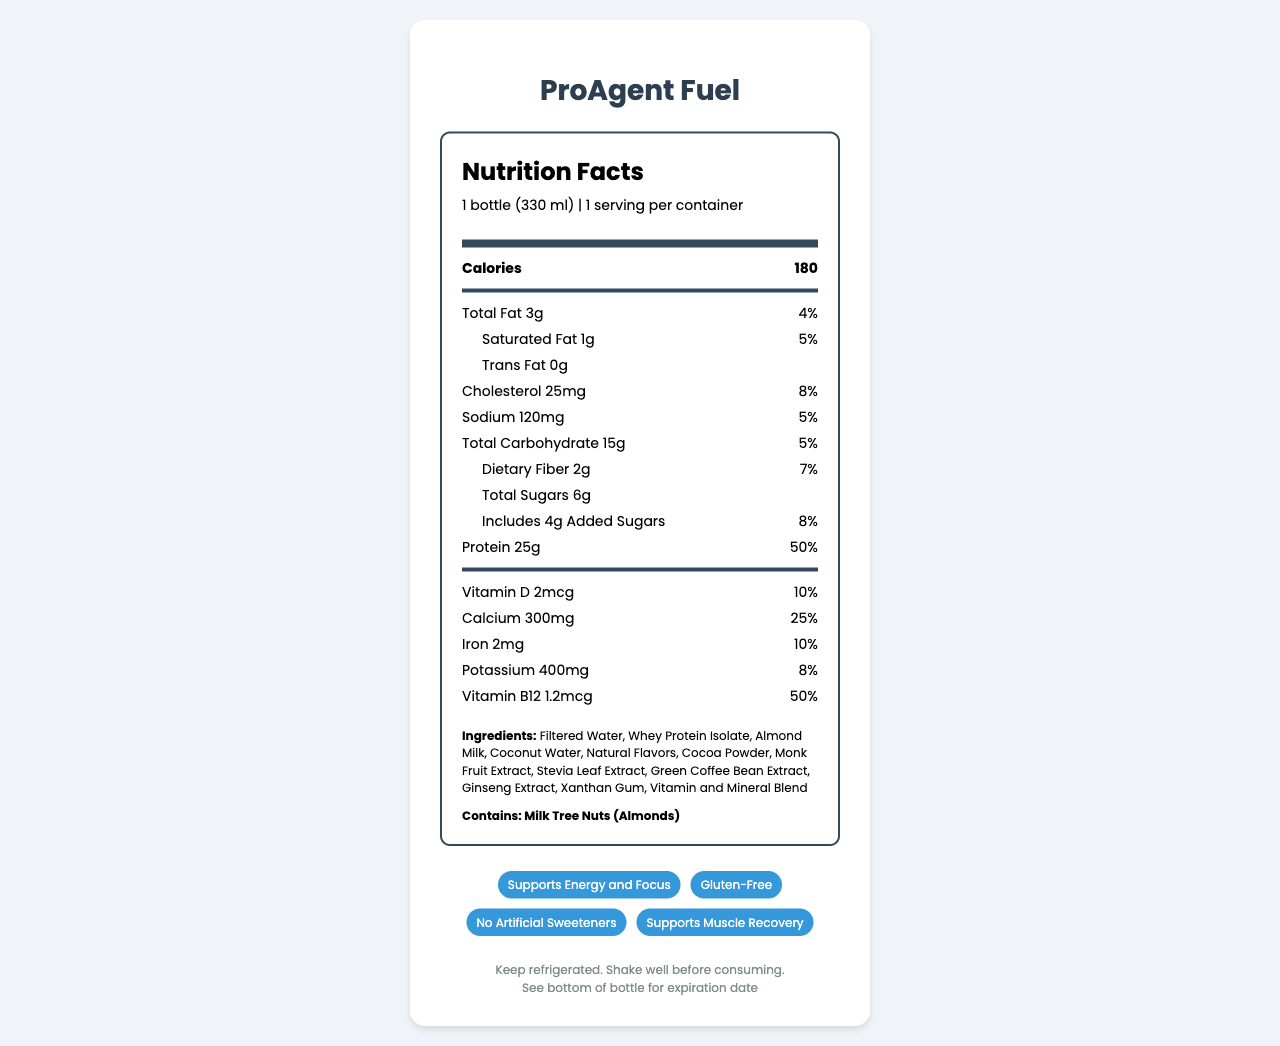what is the serving size of ProAgent Fuel? The serving size is indicated in the serving info section at the top of the nutrition label.
Answer: 1 bottle (330 ml) how many calories are in one serving of ProAgent Fuel? The calorie count is highlighted in a bolder font just below the serving size information.
Answer: 180 how many grams of protein does ProAgent Fuel provide per serving? The amount of protein per serving is listed in the nutrition facts, where it says "Protein 25g".
Answer: 25g what is the daily value percentage for calcium in a serving of ProAgent Fuel? The daily value percentage for calcium is listed next to the amount of calcium in the nutrition facts.
Answer: 25% what are the main ingredients of ProAgent Fuel? The ingredients are listed near the bottom under the "Ingredients" section.
Answer: Filtered Water, Whey Protein Isolate, Almond Milk, Coconut Water, Natural Flavors, Cocoa Powder, Monk Fruit Extract, Stevia Leaf Extract, Green Coffee Bean Extract, Ginseng Extract, Xanthan Gum, Vitamin and Mineral Blend which of the following claims is NOT made about ProAgent Fuel? A. Low Sugar B. Supports Energy and Focus C. Gluten-Free D. Supports Muscle Recovery The document includes claims about supporting energy and focus, being gluten-free, and supporting muscle recovery, but not about being low in sugar.
Answer: A what is the daily value percentage of iron provided in ProAgent Fuel? A. 5% B. 10% C. 20% D. 25% The daily value percentage of iron is indicated as 10% in the nutrition facts.
Answer: B does ProAgent Fuel contain any artificial sweeteners? The document specifically claims "No Artificial Sweeteners".
Answer: No does ProAgent Fuel require refrigeration? The storage information indicates "Keep refrigerated."
Answer: Yes summarize the main features of ProAgent Fuel. The document provides a detailed overview of the nutritional content, ingredients, and health claims of the ProAgent Fuel protein shake, along with storage instructions.
Answer: ProAgent Fuel is a protein shake designed for real estate agents on-the-go. It offers 180 calories per bottle with significant protein content (25g) and various vitamins and minerals. The product contains no artificial sweeteners, is gluten-free, and supports energy, focus, and muscle recovery. It is made with ingredients like whey protein isolate, almond milk, and coconut water. It must be kept refrigerated. what is the flavor of ProAgent Fuel? The document does not specify the flavor, it only mentions natural flavors in the ingredient list.
Answer: Cannot be determined 